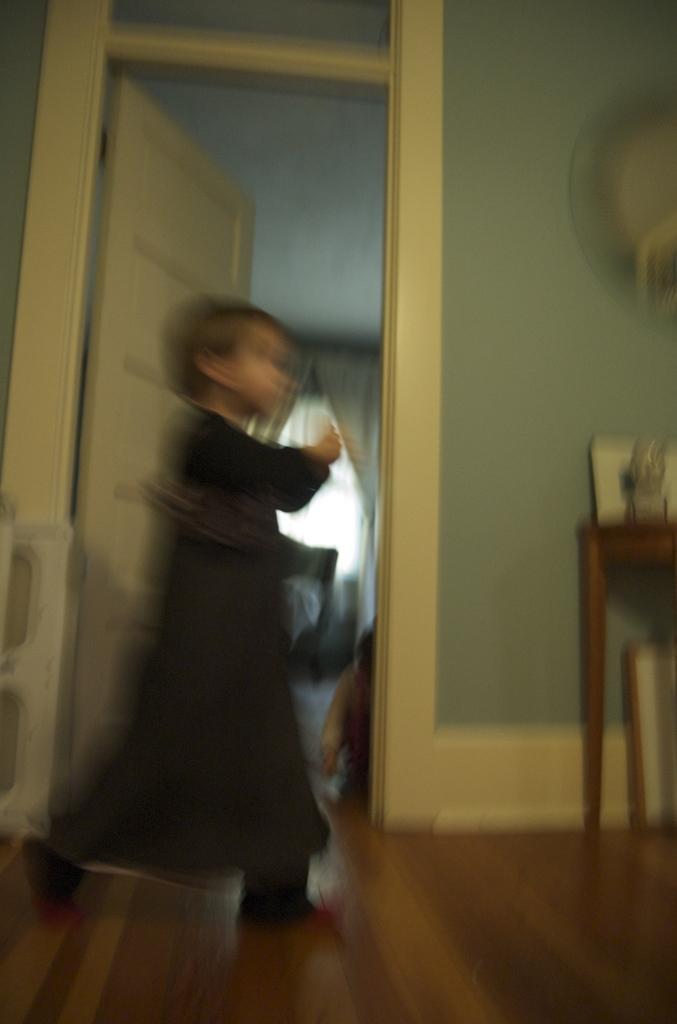Could you give a brief overview of what you see in this image? In this image I can see a girl, door, walls, table, curtains and objects.   